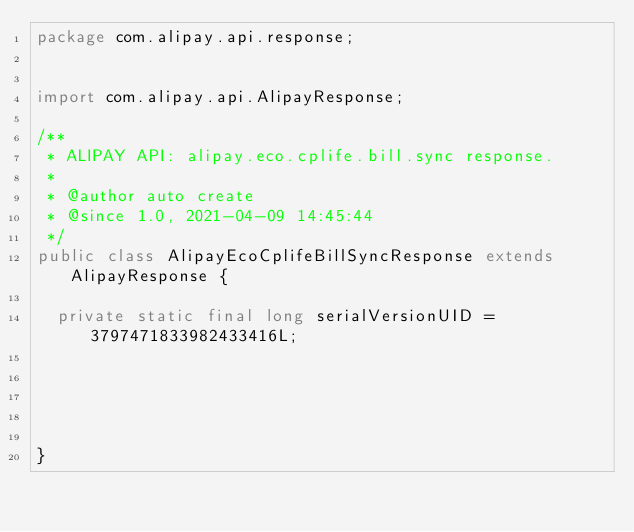Convert code to text. <code><loc_0><loc_0><loc_500><loc_500><_Java_>package com.alipay.api.response;


import com.alipay.api.AlipayResponse;

/**
 * ALIPAY API: alipay.eco.cplife.bill.sync response.
 * 
 * @author auto create
 * @since 1.0, 2021-04-09 14:45:44
 */
public class AlipayEcoCplifeBillSyncResponse extends AlipayResponse {

	private static final long serialVersionUID = 3797471833982433416L;

	

	

}
</code> 